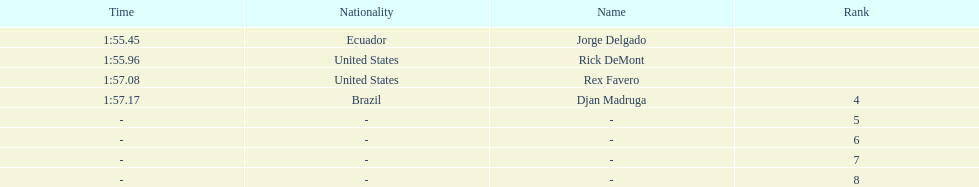Favero finished in 1:57.08. what was the next time? 1:57.17. 